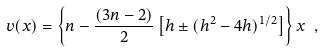Convert formula to latex. <formula><loc_0><loc_0><loc_500><loc_500>v ( x ) = \left \{ n - \frac { ( 3 n - 2 ) } { 2 } \left [ h \pm ( h ^ { 2 } - 4 h ) ^ { 1 / 2 } \right ] \right \} x \ ,</formula> 